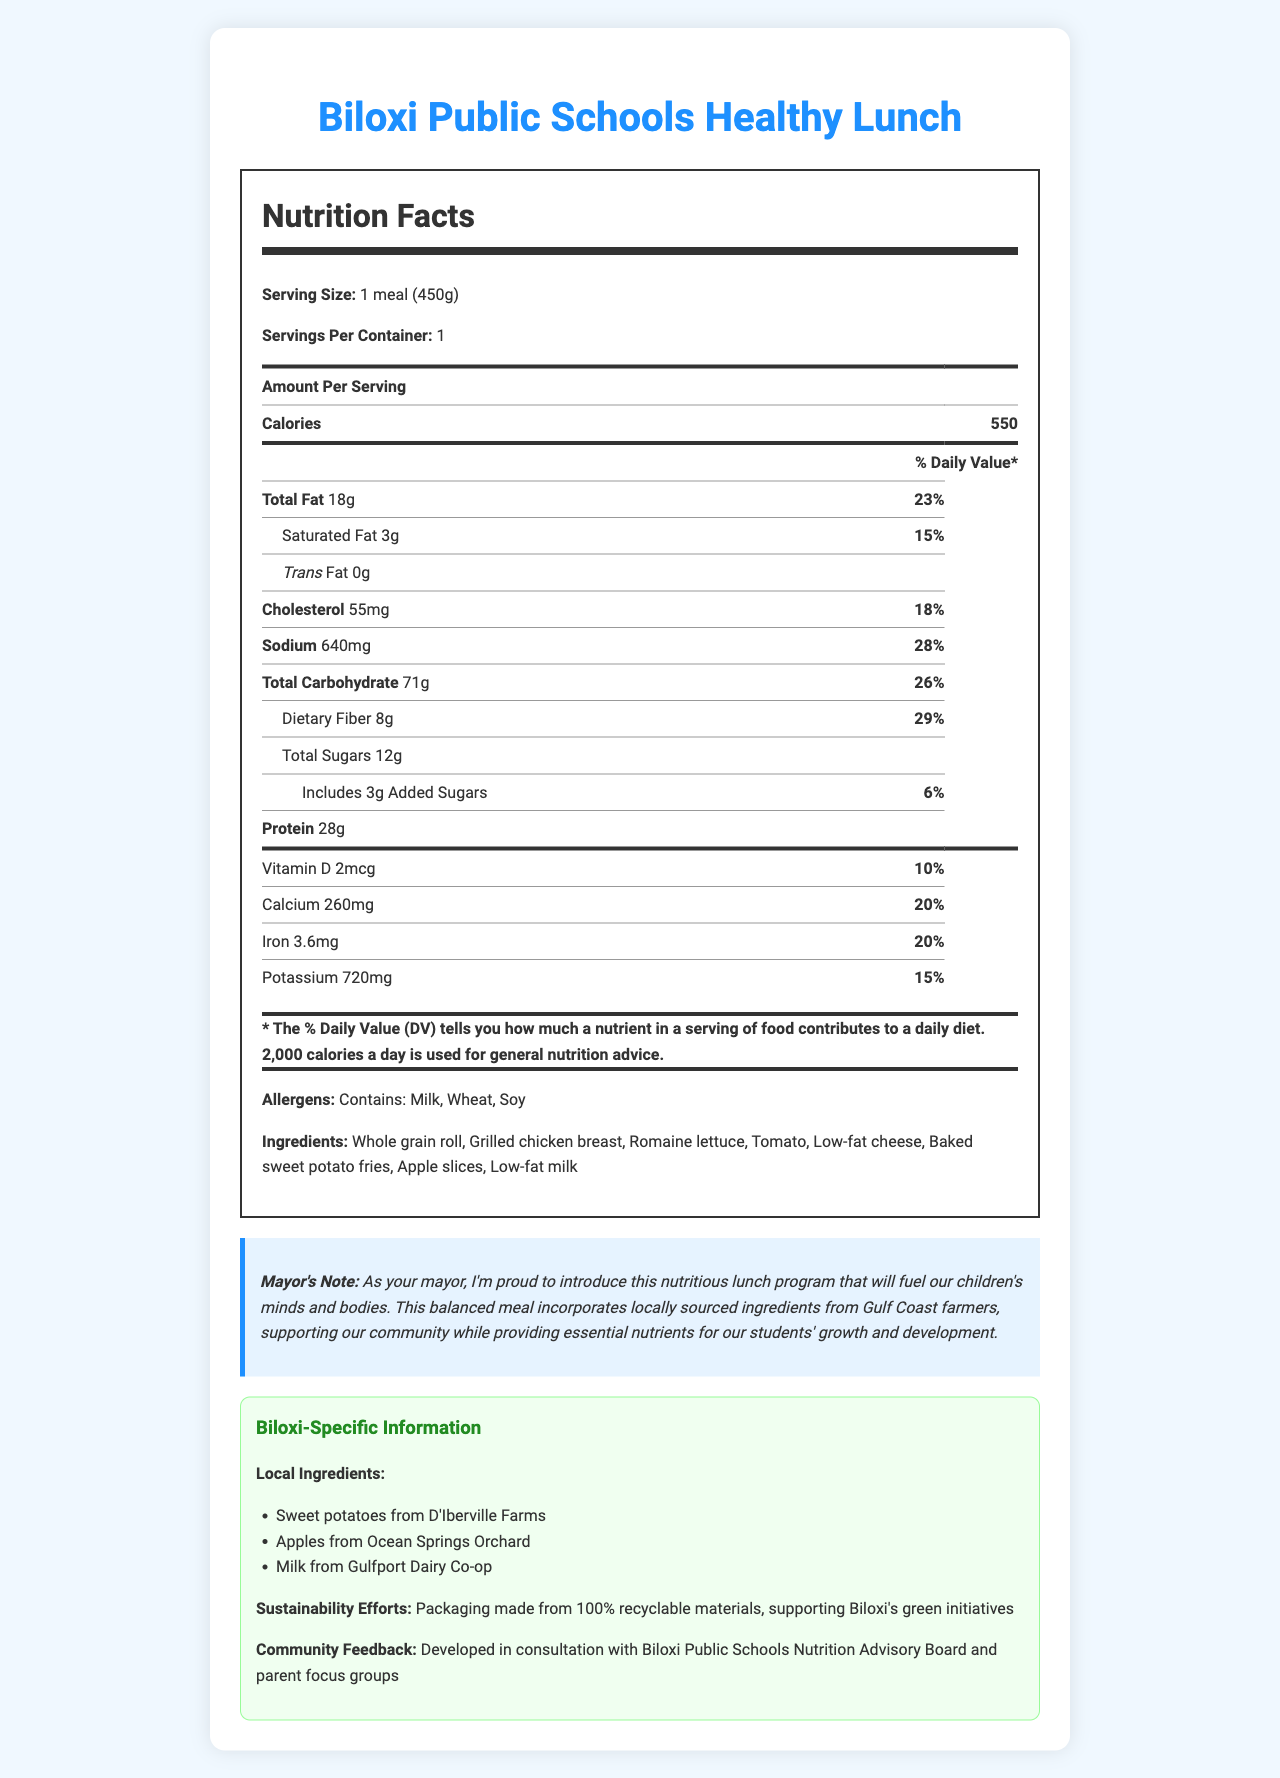Who is the target audience for the healthy lunch program? The document specifies that the "Biloxi Public Schools Healthy Lunch" is designed as a school lunch program.
Answer: Students of Biloxi Public Schools What is the serving size of the meal? The serving size is clearly listed at the top of the nutrition facts section as "1 meal (450g)."
Answer: 1 meal (450g) What is the total amount of fat in the meal? Under the nutrition facts, the "Total Fat" section lists the amount as "18g."
Answer: 18g How many grams of dietary fiber are in one serving? The dietary fiber content is listed as "8g" under the nutrition facts.
Answer: 8g What is the percentage of daily value for sodium in this meal? The percentage of daily value for sodium is listed as "28%" in the nutrition facts.
Answer: 28% Which allergens are present in this meal?
A. Milk
B. Wheat
C. Soy
D. All of the above The allergens section lists "Contains: Milk, Wheat, Soy."
Answer: D. All of the above What is the main source of protein in the meal? A. Baked sweet potato fries B. Grilled chicken breast C. Apple slices Under the ingredients section, grilled chicken breast is listed as one of the main ingredients, which is typically a primary source of protein.
Answer: B. Grilled chicken breast Is there any trans fat in the meal? The nutrition facts label states "Trans Fat 0g", indicating there is no trans fat present.
Answer: No Why is the school lunch program beneficial for the local community? The mayor's note and Biloxi-specific information sections highlight that the program uses ingredients from local farms and dairies and employs recyclable packaging, supporting both local agriculture and environmental initiatives.
Answer: It incorporates locally sourced ingredients and supports sustainability efforts. List some local ingredients used in the meal. The Biloxi-specific information section lists these local ingredients.
Answer: Sweet potatoes from D'Iberville Farms, Apples from Ocean Springs Orchard, Milk from Gulfport Dairy Co-op How many grams of added sugars are there, and what is their daily value percentage? The nutrition facts label lists "Includes 3g Added Sugars" with a daily value of "6%."
Answer: 3g, 6% Summarize the key information about the new school lunch program. The document provides detailed nutritional information, lists local ingredients, and emphasizes community and environmental benefits, all while supporting children's health and local agriculture.
Answer: The Biloxi Public Schools Healthy Lunch program provides a balanced and nutritious meal sourced from local ingredients. Each meal is 450g and contains 550 calories with 18g of total fat. It includes essential nutrients such as dietary fiber (8g), protein (28g), and vitamins and minerals, while addressing common allergens (milk, wheat, soy). Additionally, the program supports local farmers and sustainability efforts by using recyclable packaging. The mayor endorses the program for both its nutritional value and community support. What type of farm provides the sweet potatoes for the meal? The Biloxi-specific information details that sweet potatoes are sourced from D'Iberville Farms.
Answer: D'Iberville Farms Which ingredient in the meal contains cheese? The ingredients list includes "Low-fat cheese," indicating cheese is part of the meal.
Answer: Low-fat cheese What is the source of calcium in the meal? The document specifies that the milk used comes from the Gulfport Dairy Co-op.
Answer: Milk from Gulfport Dairy Co-op Can the exact number of students benefiting from this lunch program be found in the document? The document does not provide any details regarding the exact number of students who will benefit from the lunch program.
Answer: Not enough information 